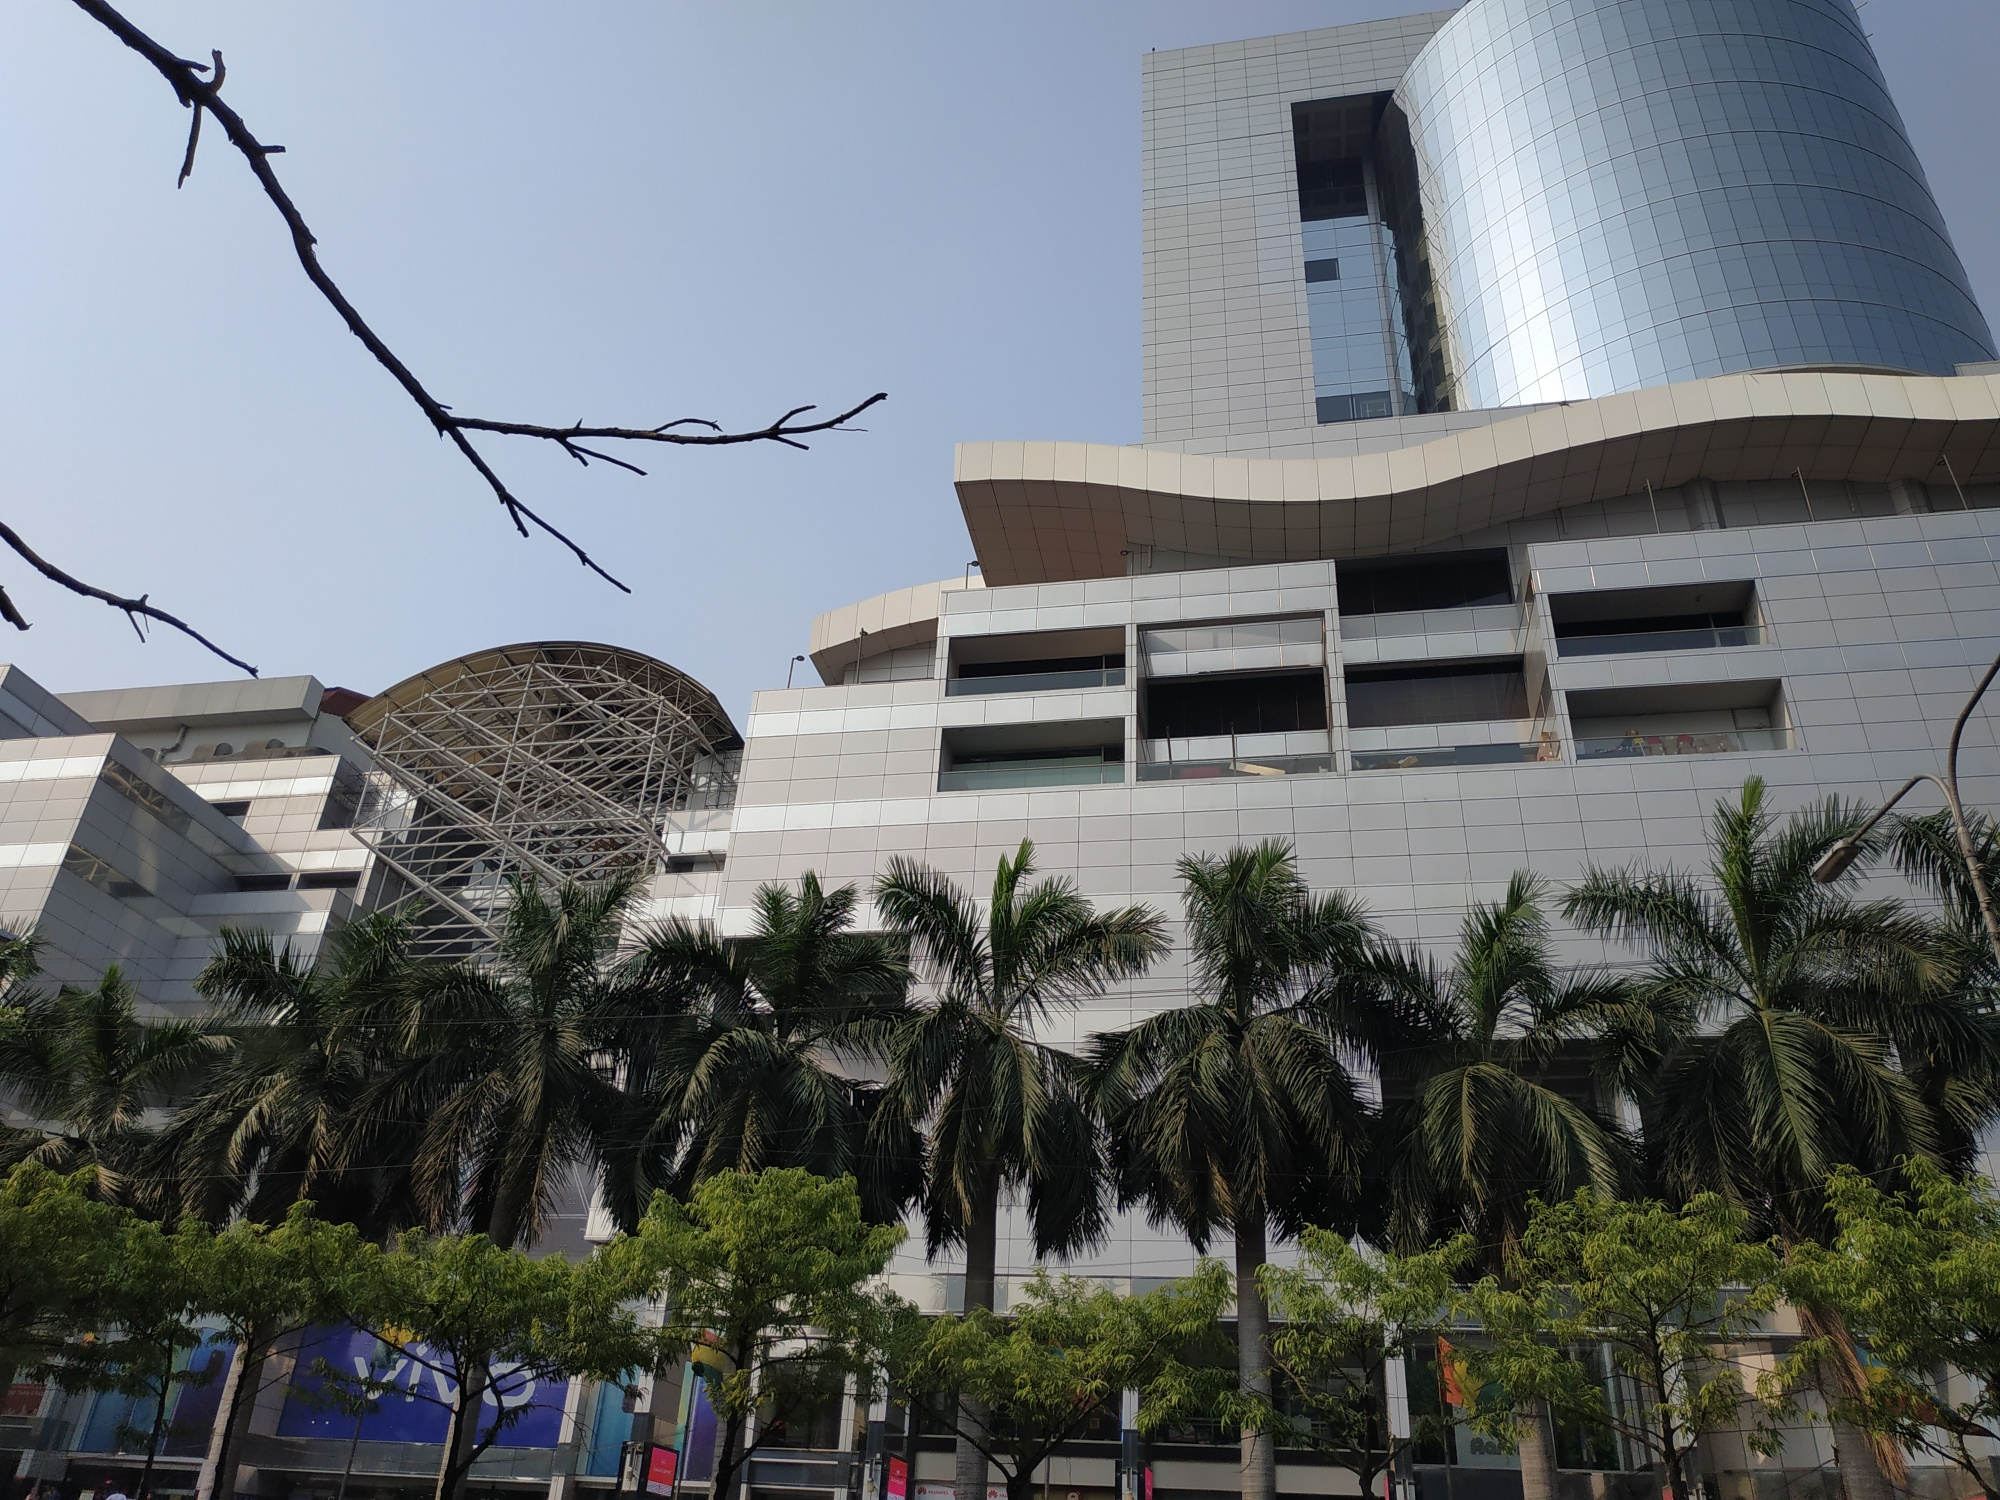What do the architectural features of this building signify about modern urban infrastructure? The architectural features of this building, characterized by its sleek glass facade, clean lines, and innovative design elements such as the large metal dome, reflect the advancements in modern urban infrastructure. These design elements signify a trend towards futuristic aesthetics that prioritize both functionality and visual impact. The use of glass maximizes natural light, creating an inviting atmosphere while also promoting energy efficiency. The building’s towering presence and expansive glass panels illustrate the urban aspiration for verticality and grandeur in limited space, a common trait in densely populated city-states like Singapore. Additionally, the surrounding greenery suggests an effort to incorporate natural elements into urban environments, promoting sustainability and a healthier living space for residents. 